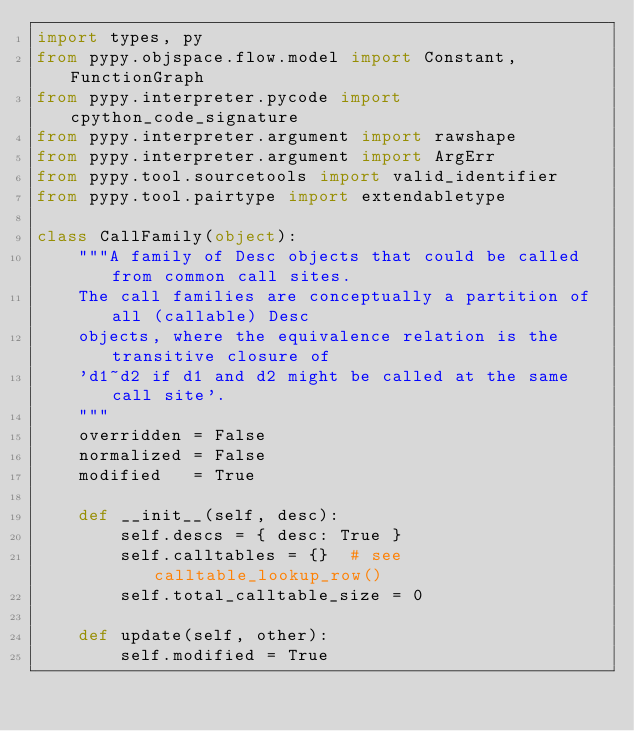<code> <loc_0><loc_0><loc_500><loc_500><_Python_>import types, py
from pypy.objspace.flow.model import Constant, FunctionGraph
from pypy.interpreter.pycode import cpython_code_signature
from pypy.interpreter.argument import rawshape
from pypy.interpreter.argument import ArgErr
from pypy.tool.sourcetools import valid_identifier
from pypy.tool.pairtype import extendabletype

class CallFamily(object):
    """A family of Desc objects that could be called from common call sites.
    The call families are conceptually a partition of all (callable) Desc
    objects, where the equivalence relation is the transitive closure of
    'd1~d2 if d1 and d2 might be called at the same call site'.
    """
    overridden = False
    normalized = False
    modified   = True

    def __init__(self, desc):
        self.descs = { desc: True }
        self.calltables = {}  # see calltable_lookup_row()
        self.total_calltable_size = 0

    def update(self, other):
        self.modified = True</code> 